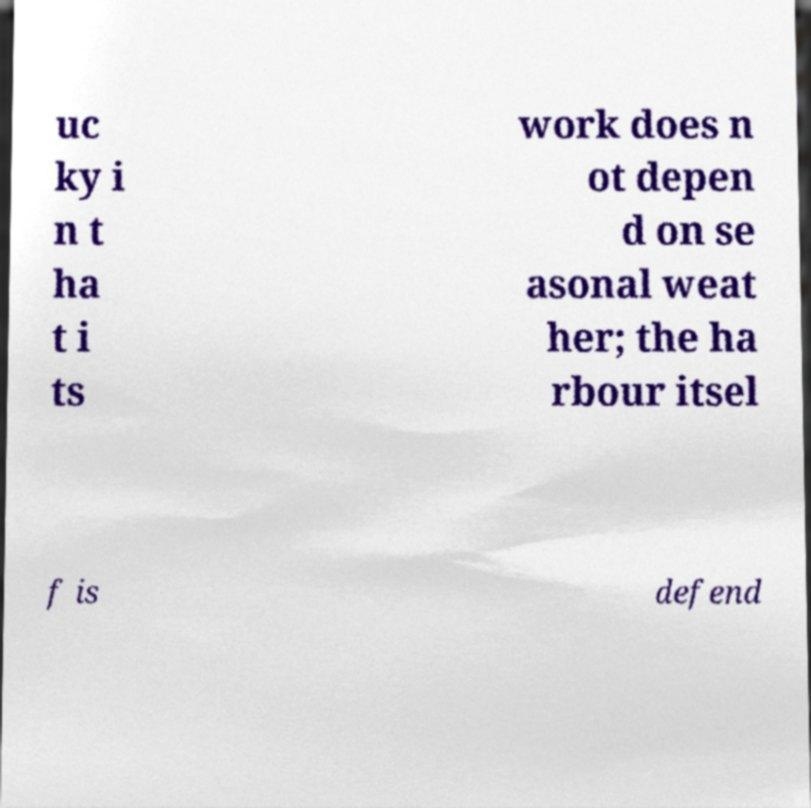There's text embedded in this image that I need extracted. Can you transcribe it verbatim? uc ky i n t ha t i ts work does n ot depen d on se asonal weat her; the ha rbour itsel f is defend 